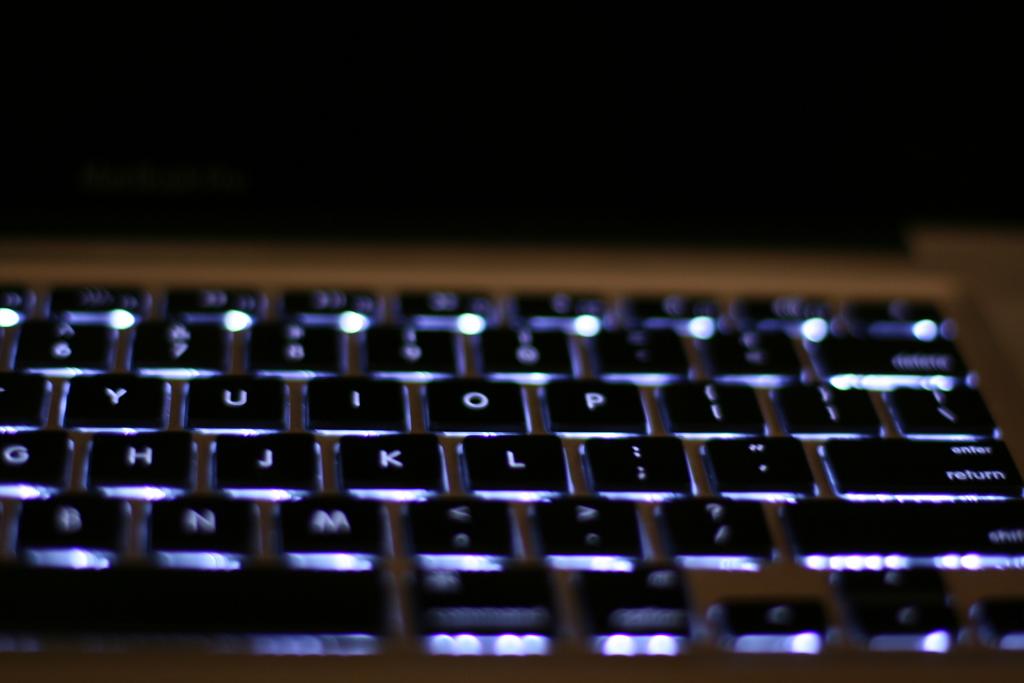What is the key on the right of o?
Make the answer very short. P. 